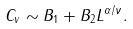<formula> <loc_0><loc_0><loc_500><loc_500>C _ { v } \sim B _ { 1 } + B _ { 2 } L ^ { \alpha / \nu } .</formula> 